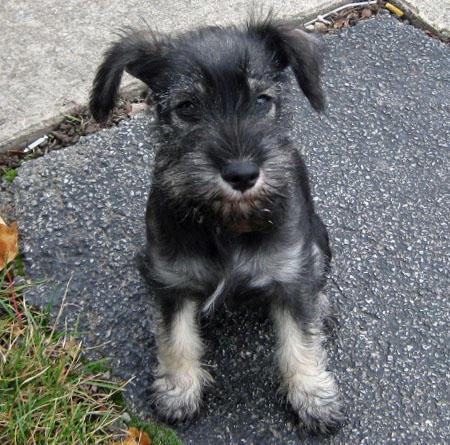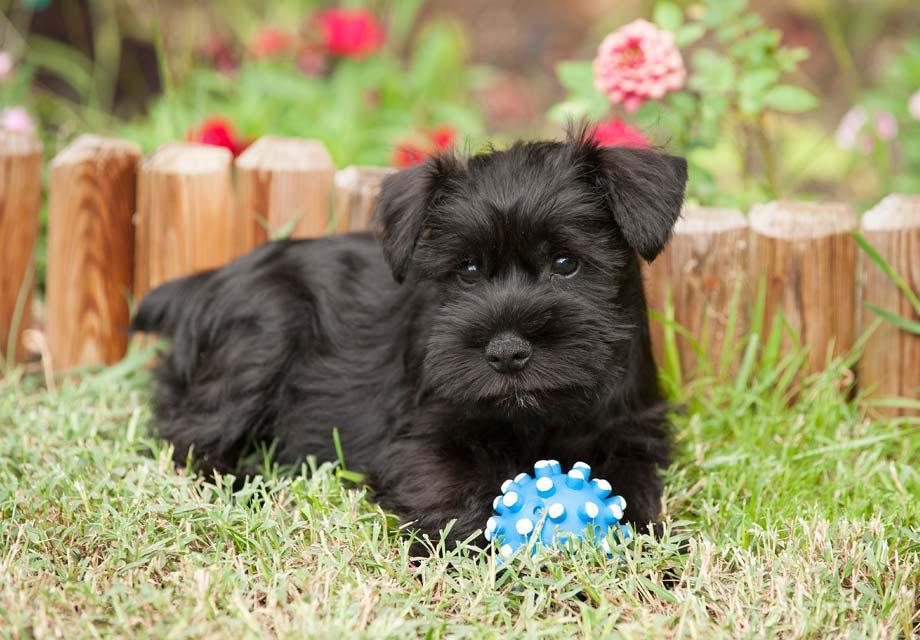The first image is the image on the left, the second image is the image on the right. Assess this claim about the two images: "In at least one image, there is a single dog with white paws and ears sitting facing left.". Correct or not? Answer yes or no. No. The first image is the image on the left, the second image is the image on the right. For the images shown, is this caption "The dogs have collars on them." true? Answer yes or no. No. 